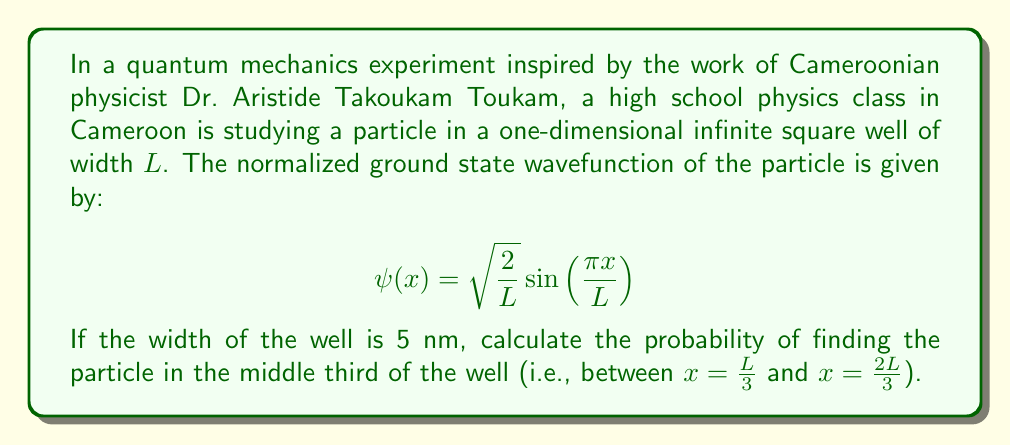Provide a solution to this math problem. To solve this problem, we need to follow these steps:

1) The probability of finding the particle in a region is given by the integral of the probability density $|\psi(x)|^2$ over that region.

2) We need to integrate $|\psi(x)|^2$ from $x = \frac{L}{3}$ to $x = \frac{2L}{3}$:

   $$P = \int_{\frac{L}{3}}^{\frac{2L}{3}} |\psi(x)|^2 dx$$

3) Let's calculate $|\psi(x)|^2$:

   $$|\psi(x)|^2 = \left(\sqrt{\frac{2}{L}} \sin\left(\frac{\pi x}{L}\right)\right)^2 = \frac{2}{L} \sin^2\left(\frac{\pi x}{L}\right)$$

4) Now our integral becomes:

   $$P = \int_{\frac{L}{3}}^{\frac{2L}{3}} \frac{2}{L} \sin^2\left(\frac{\pi x}{L}\right) dx$$

5) To solve this, we can use the trigonometric identity:

   $$\sin^2 x = \frac{1}{2}(1 - \cos 2x)$$

6) Applying this to our integral:

   $$P = \frac{2}{L} \int_{\frac{L}{3}}^{\frac{2L}{3}} \frac{1}{2}\left(1 - \cos\left(\frac{2\pi x}{L}\right)\right) dx$$

7) Simplifying:

   $$P = \frac{1}{L} \int_{\frac{L}{3}}^{\frac{2L}{3}} \left(1 - \cos\left(\frac{2\pi x}{L}\right)\right) dx$$

8) Integrating:

   $$P = \frac{1}{L} \left[x - \frac{L}{2\pi} \sin\left(\frac{2\pi x}{L}\right)\right]_{\frac{L}{3}}^{\frac{2L}{3}}$$

9) Evaluating the limits:

   $$P = \frac{1}{L} \left[\frac{2L}{3} - \frac{L}{2\pi} \sin\left(\frac{4\pi}{3}\right) - \frac{L}{3} + \frac{L}{2\pi} \sin\left(\frac{2\pi}{3}\right)\right]$$

10) Simplifying:

    $$P = \frac{1}{3} - \frac{1}{2\pi} \left[\sin\left(\frac{4\pi}{3}\right) - \sin\left(\frac{2\pi}{3}\right)\right]$$

11) Note that $\sin(\frac{4\pi}{3}) = -\frac{\sqrt{3}}{2}$ and $\sin(\frac{2\pi}{3}) = \frac{\sqrt{3}}{2}$

12) Therefore:

    $$P = \frac{1}{3} - \frac{1}{2\pi} \left[-\frac{\sqrt{3}}{2} - \frac{\sqrt{3}}{2}\right] = \frac{1}{3} + \frac{\sqrt{3}}{2\pi}$$

13) This result is independent of $L$, so we don't need to use the given value of 5 nm.
Answer: The probability of finding the particle in the middle third of the well is $\frac{1}{3} + \frac{\sqrt{3}}{2\pi} \approx 0.6057$ or about 60.57%. 